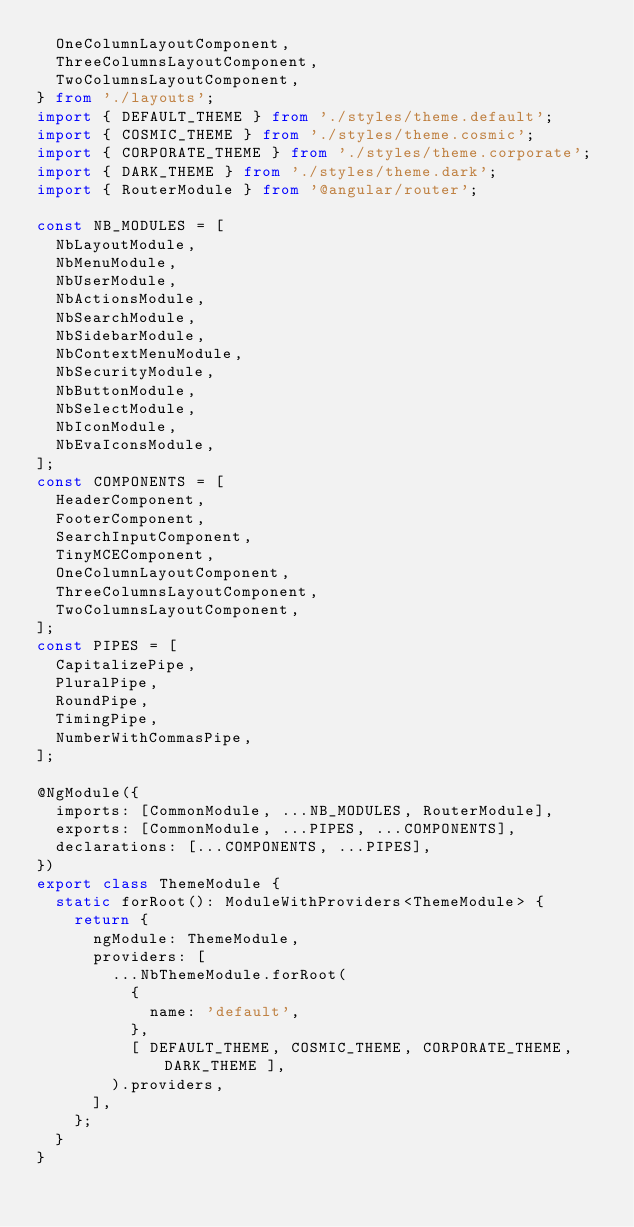<code> <loc_0><loc_0><loc_500><loc_500><_TypeScript_>  OneColumnLayoutComponent,
  ThreeColumnsLayoutComponent,
  TwoColumnsLayoutComponent,
} from './layouts';
import { DEFAULT_THEME } from './styles/theme.default';
import { COSMIC_THEME } from './styles/theme.cosmic';
import { CORPORATE_THEME } from './styles/theme.corporate';
import { DARK_THEME } from './styles/theme.dark';
import { RouterModule } from '@angular/router';

const NB_MODULES = [
  NbLayoutModule,
  NbMenuModule,
  NbUserModule,
  NbActionsModule,
  NbSearchModule,
  NbSidebarModule,
  NbContextMenuModule,
  NbSecurityModule,
  NbButtonModule,
  NbSelectModule,
  NbIconModule,
  NbEvaIconsModule,
];
const COMPONENTS = [
  HeaderComponent,
  FooterComponent,
  SearchInputComponent,
  TinyMCEComponent,
  OneColumnLayoutComponent,
  ThreeColumnsLayoutComponent,
  TwoColumnsLayoutComponent,
];
const PIPES = [
  CapitalizePipe,
  PluralPipe,
  RoundPipe,
  TimingPipe,
  NumberWithCommasPipe,
];

@NgModule({
  imports: [CommonModule, ...NB_MODULES, RouterModule],
  exports: [CommonModule, ...PIPES, ...COMPONENTS],
  declarations: [...COMPONENTS, ...PIPES],
})
export class ThemeModule {
  static forRoot(): ModuleWithProviders<ThemeModule> {
    return {
      ngModule: ThemeModule,
      providers: [
        ...NbThemeModule.forRoot(
          {
            name: 'default',
          },
          [ DEFAULT_THEME, COSMIC_THEME, CORPORATE_THEME, DARK_THEME ],
        ).providers,
      ],
    };
  }
}
</code> 